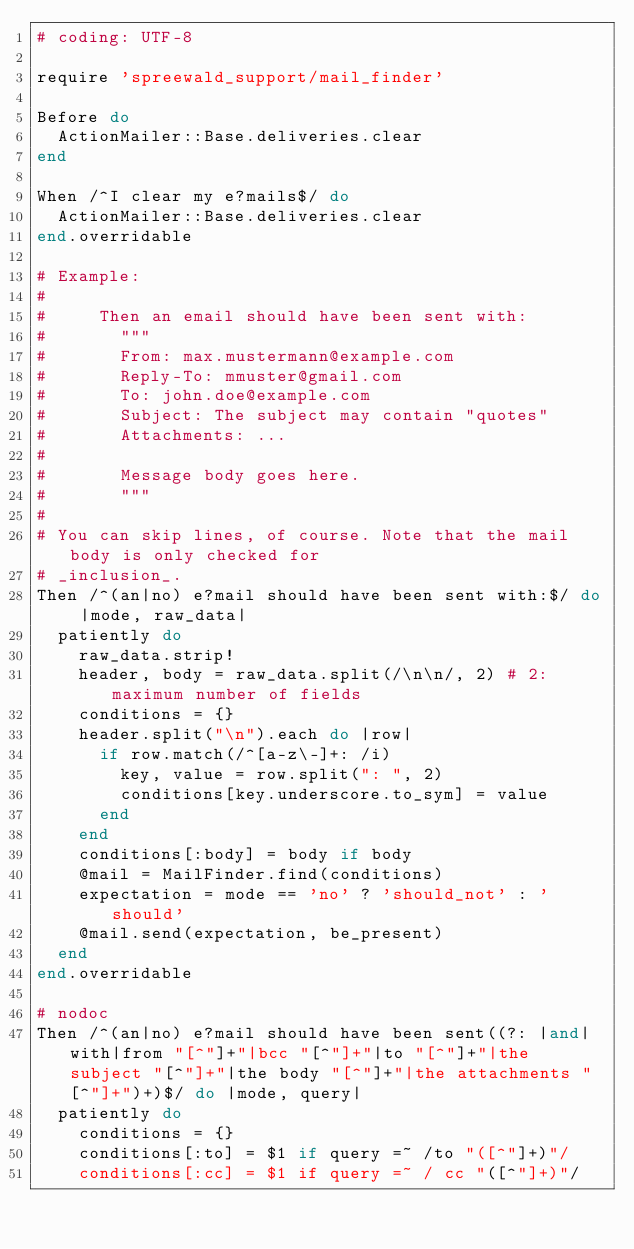Convert code to text. <code><loc_0><loc_0><loc_500><loc_500><_Ruby_># coding: UTF-8

require 'spreewald_support/mail_finder'

Before do
  ActionMailer::Base.deliveries.clear
end

When /^I clear my e?mails$/ do
  ActionMailer::Base.deliveries.clear
end.overridable

# Example:
#
#     Then an email should have been sent with:
#       """
#       From: max.mustermann@example.com
#       Reply-To: mmuster@gmail.com
#       To: john.doe@example.com
#       Subject: The subject may contain "quotes"
#       Attachments: ...
#
#       Message body goes here.
#       """
#
# You can skip lines, of course. Note that the mail body is only checked for
# _inclusion_.
Then /^(an|no) e?mail should have been sent with:$/ do |mode, raw_data|
  patiently do
    raw_data.strip!
    header, body = raw_data.split(/\n\n/, 2) # 2: maximum number of fields
    conditions = {}
    header.split("\n").each do |row|
      if row.match(/^[a-z\-]+: /i)
        key, value = row.split(": ", 2)
        conditions[key.underscore.to_sym] = value
      end
    end
    conditions[:body] = body if body
    @mail = MailFinder.find(conditions)
    expectation = mode == 'no' ? 'should_not' : 'should'
    @mail.send(expectation, be_present)
  end
end.overridable

# nodoc
Then /^(an|no) e?mail should have been sent((?: |and|with|from "[^"]+"|bcc "[^"]+"|to "[^"]+"|the subject "[^"]+"|the body "[^"]+"|the attachments "[^"]+")+)$/ do |mode, query|
  patiently do
    conditions = {}
    conditions[:to] = $1 if query =~ /to "([^"]+)"/
    conditions[:cc] = $1 if query =~ / cc "([^"]+)"/</code> 